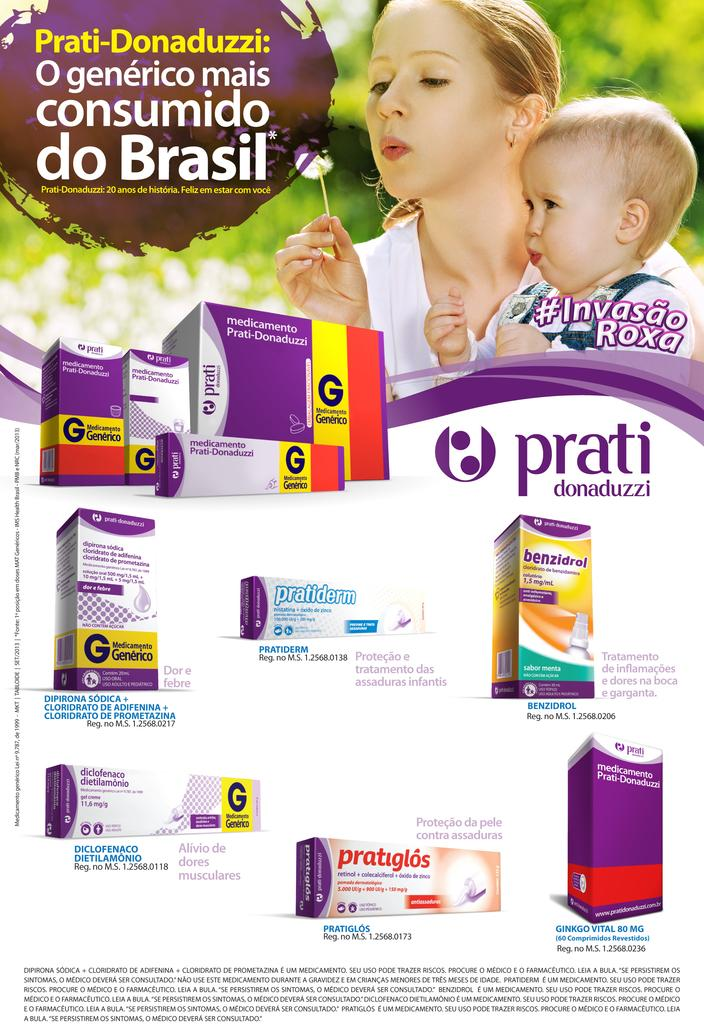<image>
Summarize the visual content of the image. An ad for various products by prati donaduzzi has a lot of purple on it. 